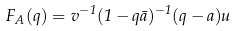<formula> <loc_0><loc_0><loc_500><loc_500>F _ { A } ( q ) = v ^ { - 1 } ( 1 - q \bar { a } ) ^ { - 1 } ( q - a ) u</formula> 